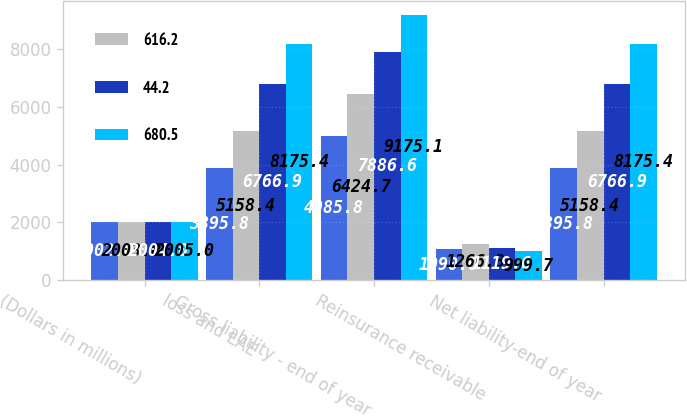<chart> <loc_0><loc_0><loc_500><loc_500><stacked_bar_chart><ecel><fcel>(Dollars in millions)<fcel>loss and LAE<fcel>Gross liability - end of year<fcel>Reinsurance receivable<fcel>Net liability-end of year<nl><fcel>nan<fcel>2002<fcel>3895.8<fcel>4985.8<fcel>1090<fcel>3895.8<nl><fcel>616.2<fcel>2003<fcel>5158.4<fcel>6424.7<fcel>1266.3<fcel>5158.4<nl><fcel>44.2<fcel>2004<fcel>6766.9<fcel>7886.6<fcel>1119.6<fcel>6766.9<nl><fcel>680.5<fcel>2005<fcel>8175.4<fcel>9175.1<fcel>999.7<fcel>8175.4<nl></chart> 